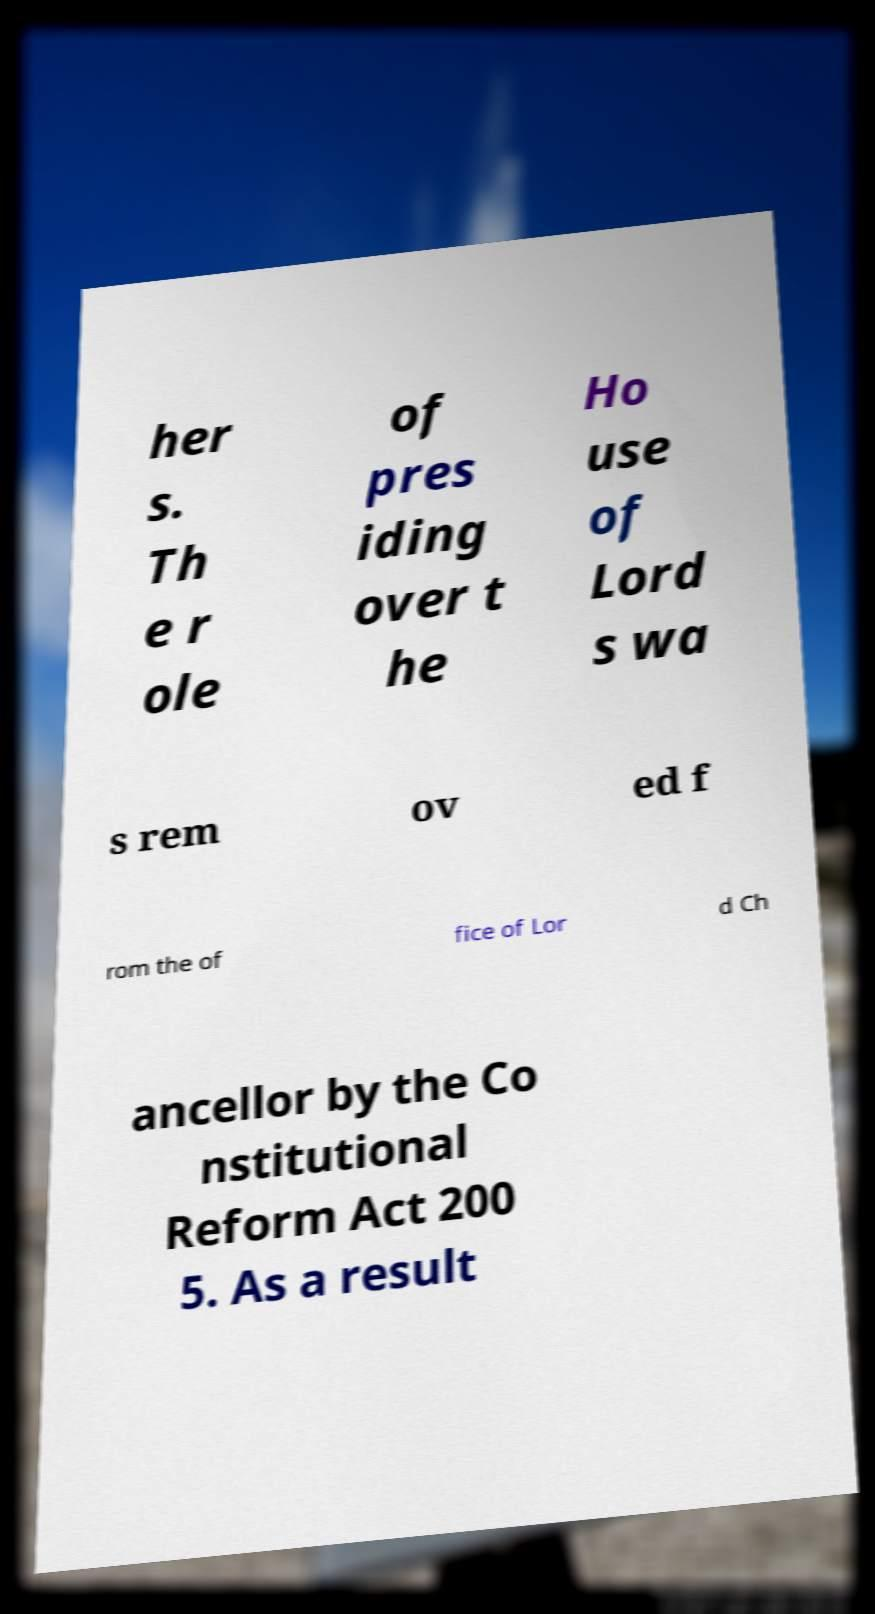Can you accurately transcribe the text from the provided image for me? her s. Th e r ole of pres iding over t he Ho use of Lord s wa s rem ov ed f rom the of fice of Lor d Ch ancellor by the Co nstitutional Reform Act 200 5. As a result 